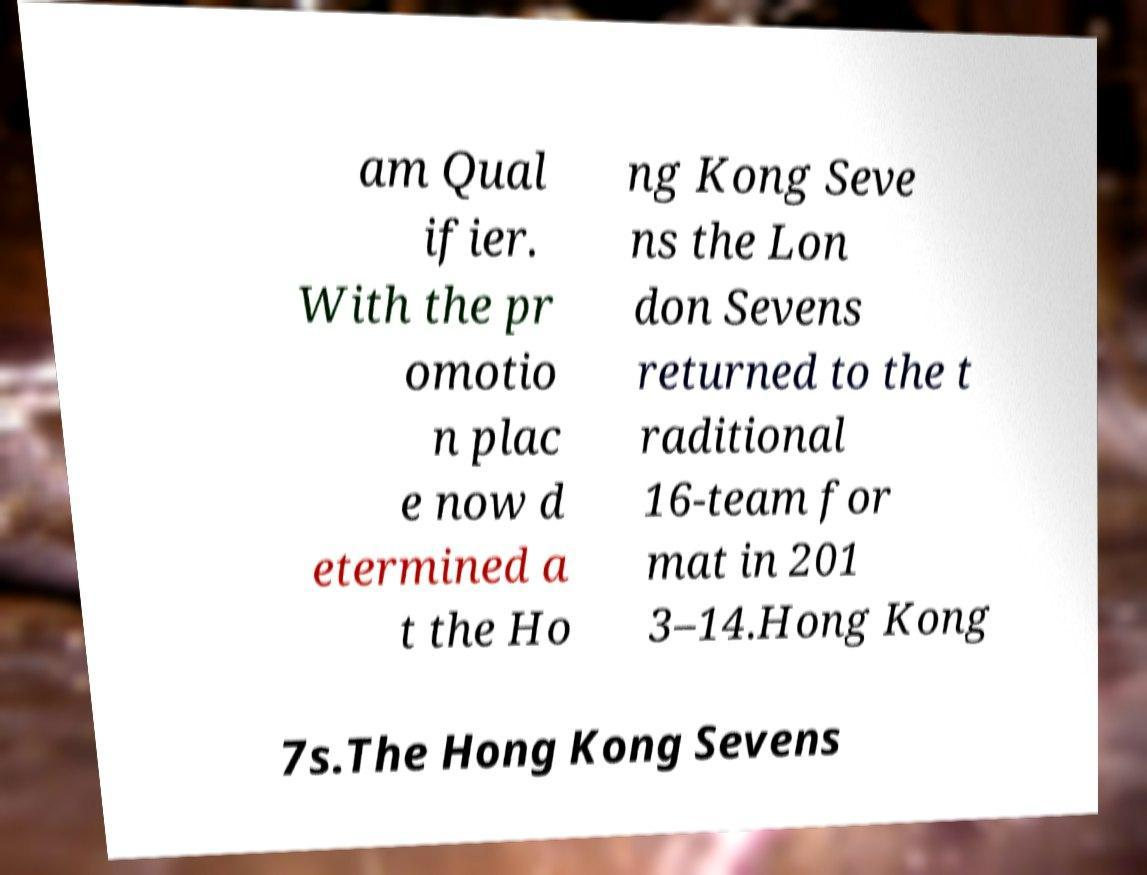Can you accurately transcribe the text from the provided image for me? am Qual ifier. With the pr omotio n plac e now d etermined a t the Ho ng Kong Seve ns the Lon don Sevens returned to the t raditional 16-team for mat in 201 3–14.Hong Kong 7s.The Hong Kong Sevens 